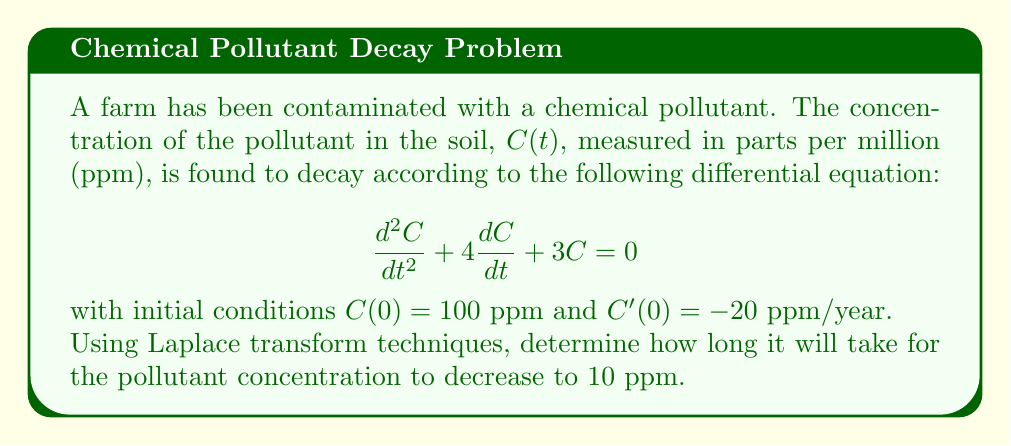What is the answer to this math problem? Let's solve this problem step by step using Laplace transforms:

1) First, we take the Laplace transform of both sides of the differential equation:

   $$\mathcal{L}\{C''(t)\} + 4\mathcal{L}\{C'(t)\} + 3\mathcal{L}\{C(t)\} = 0$$

2) Using the properties of Laplace transforms:

   $$[s^2C(s) - sC(0) - C'(0)] + 4[sC(s) - C(0)] + 3C(s) = 0$$

3) Substituting the initial conditions:

   $$[s^2C(s) - 100s + 20] + 4[sC(s) - 100] + 3C(s) = 0$$

4) Simplifying:

   $$s^2C(s) - 100s + 20 + 4sC(s) - 400 + 3C(s) = 0$$
   $$(s^2 + 4s + 3)C(s) = 100s + 380$$

5) Solving for C(s):

   $$C(s) = \frac{100s + 380}{s^2 + 4s + 3} = \frac{100(s + 3.8)}{(s + 1)(s + 3)}$$

6) Using partial fraction decomposition:

   $$C(s) = \frac{A}{s + 1} + \frac{B}{s + 3}$$

   where $A = 50$ and $B = 50$

7) Taking the inverse Laplace transform:

   $$C(t) = 50e^{-t} + 50e^{-3t}$$

8) To find when C(t) = 10, we solve:

   $$10 = 50e^{-t} + 50e^{-3t}$$

9) This equation can't be solved analytically. We need to use numerical methods or graphical solutions. Using a numerical solver, we find:

   $$t \approx 2.3026 \text{ years}$$
Answer: It will take approximately 2.3026 years for the pollutant concentration to decrease to 10 ppm. 